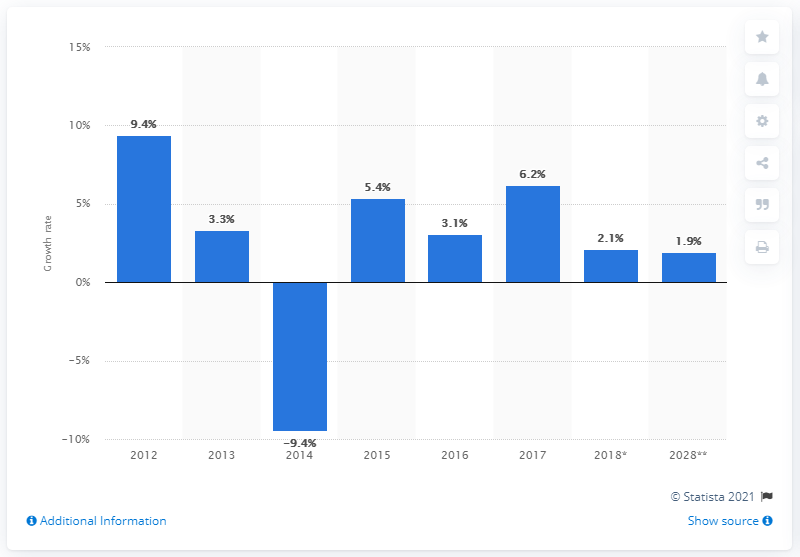Outline some significant characteristics in this image. The impact of the domestic supply chain on travel and tourism in the UK grew by 6.2% in 2017, according to recent data. 